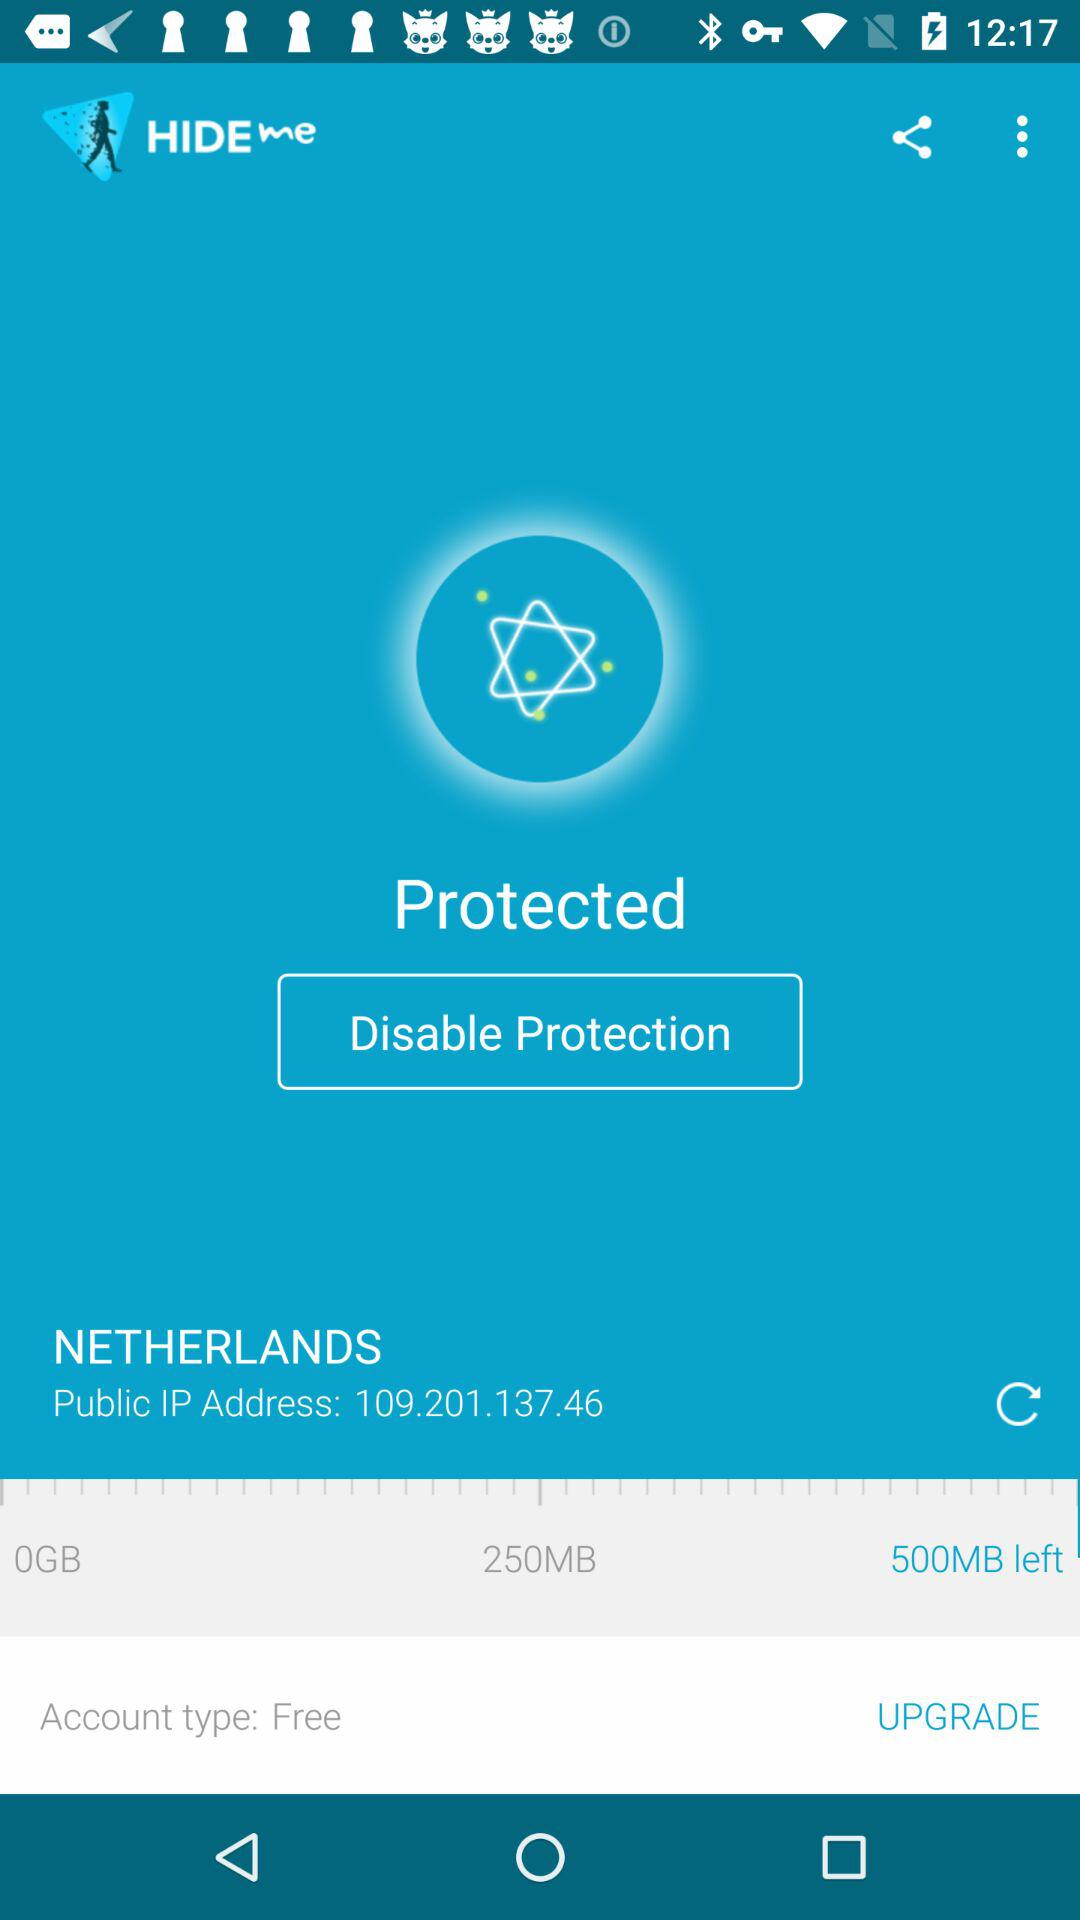How much does it cost to upgrade?
When the provided information is insufficient, respond with <no answer>. <no answer> 